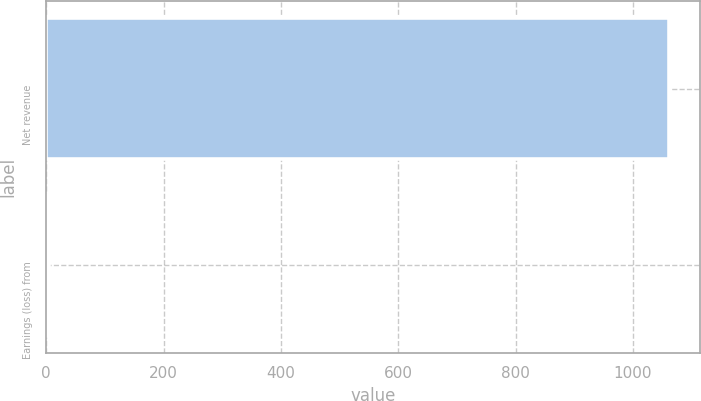Convert chart. <chart><loc_0><loc_0><loc_500><loc_500><bar_chart><fcel>Net revenue<fcel>Earnings (loss) from<nl><fcel>1061<fcel>4.6<nl></chart> 